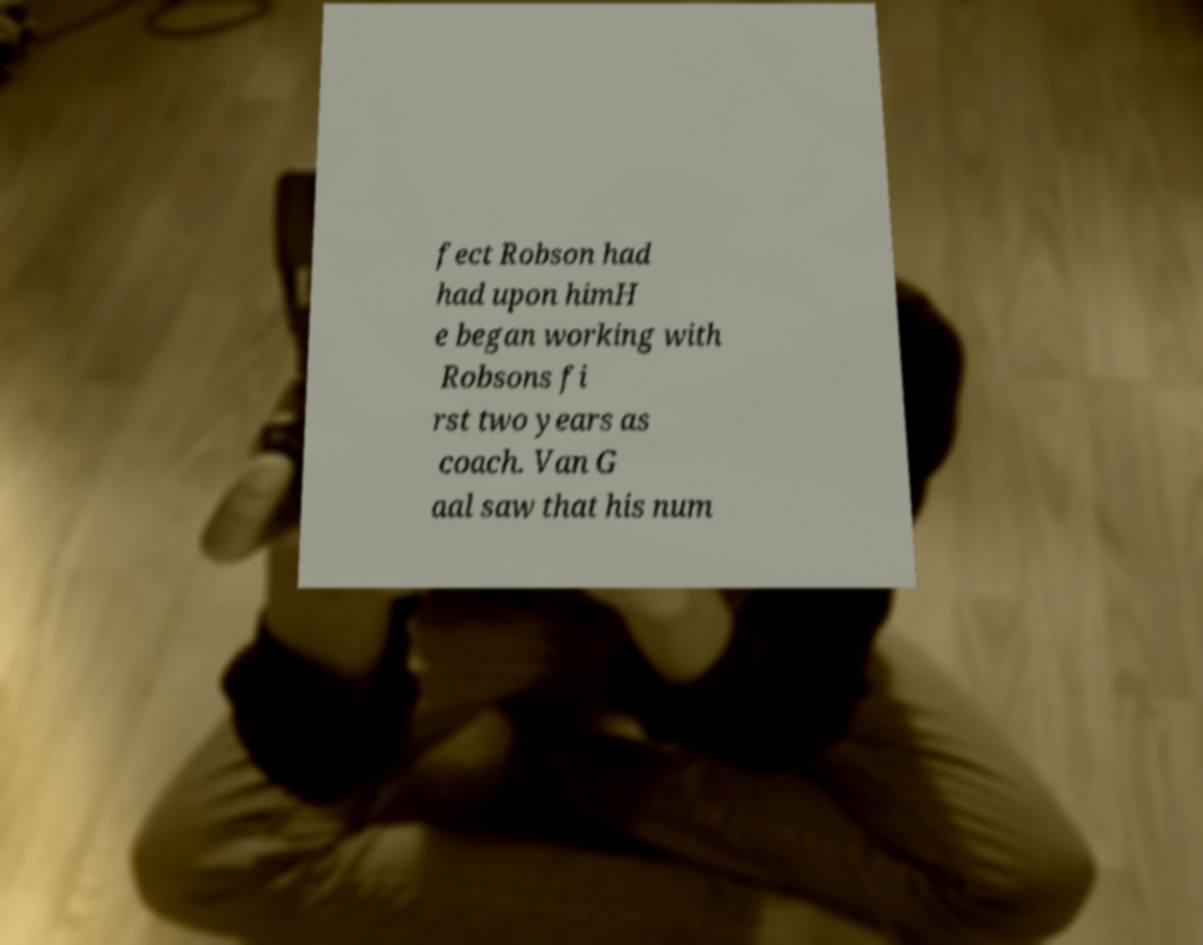There's text embedded in this image that I need extracted. Can you transcribe it verbatim? fect Robson had had upon himH e began working with Robsons fi rst two years as coach. Van G aal saw that his num 